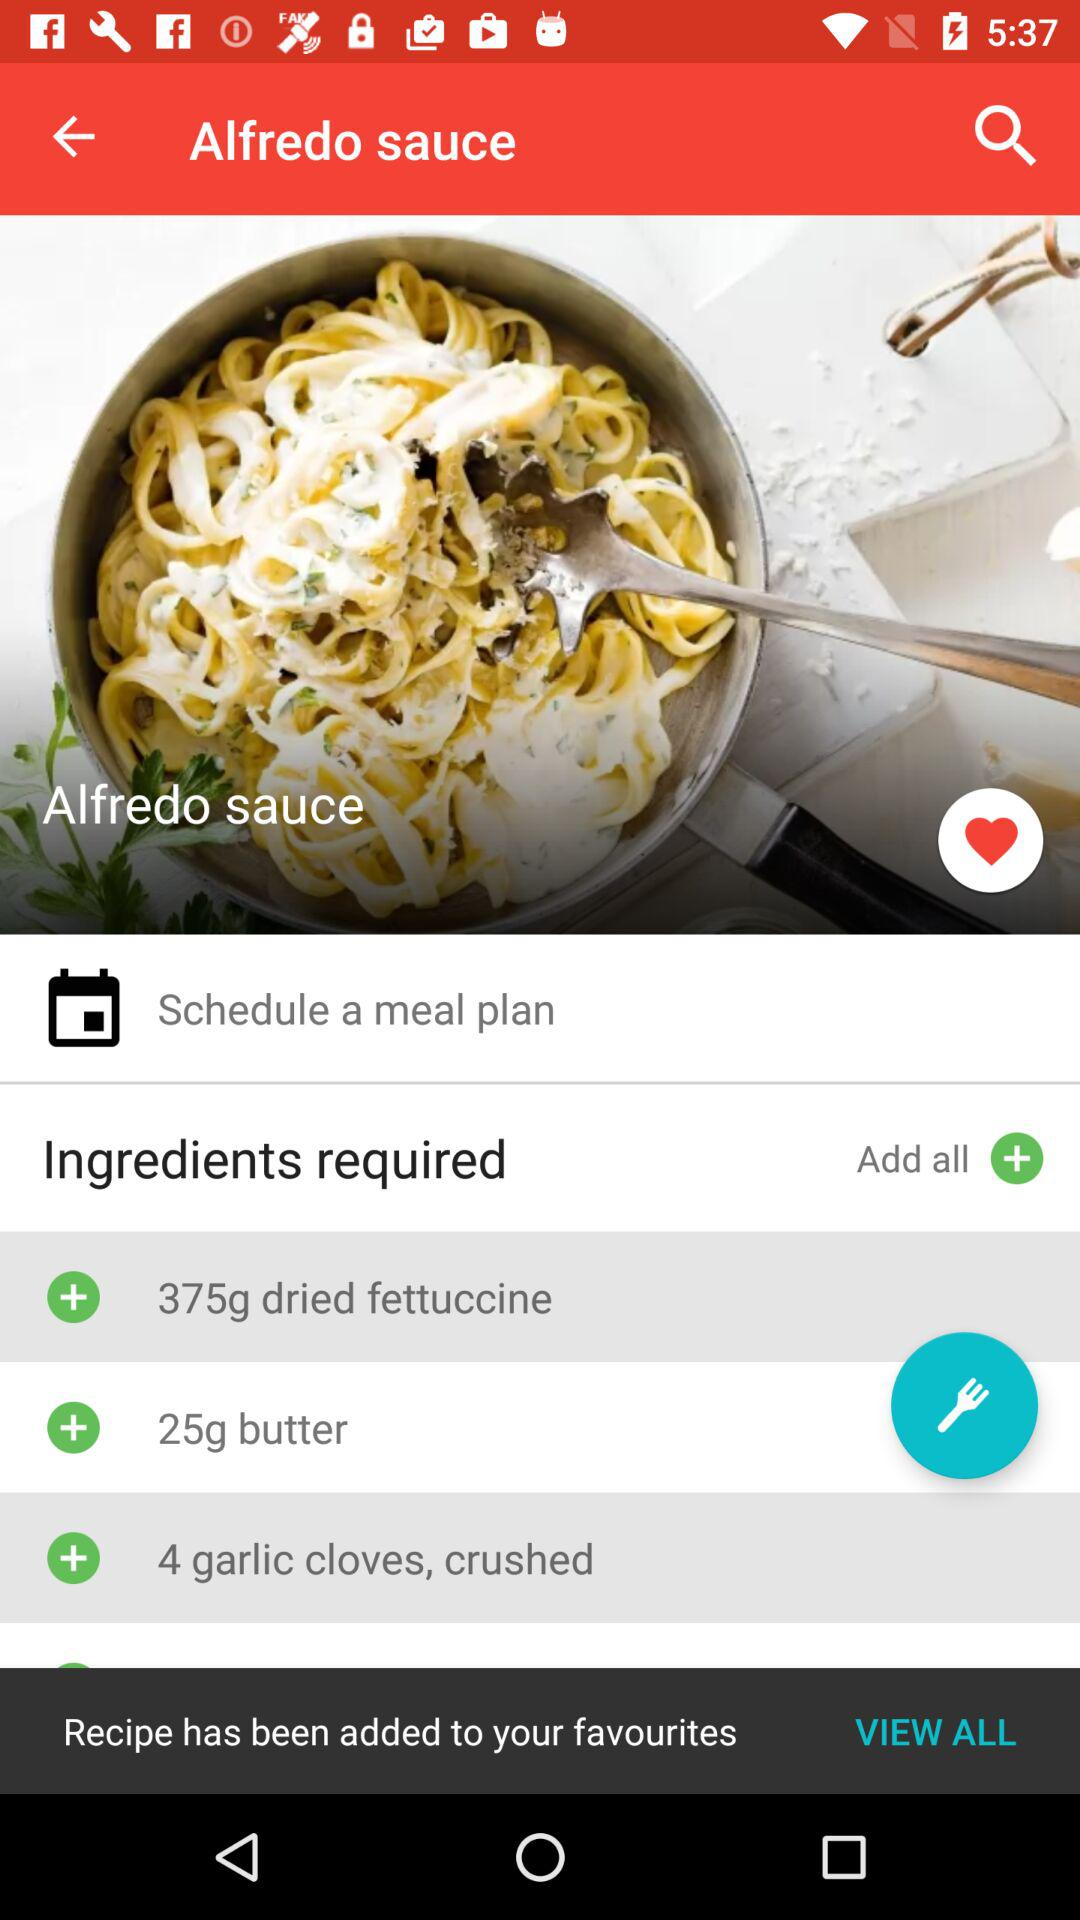What ingredients are added to Alfredo sauce? The ingredients added to Alfredo sauce are : "375g dried fettuccine", "25g butter", and "4 garlic cloves, crushed". 